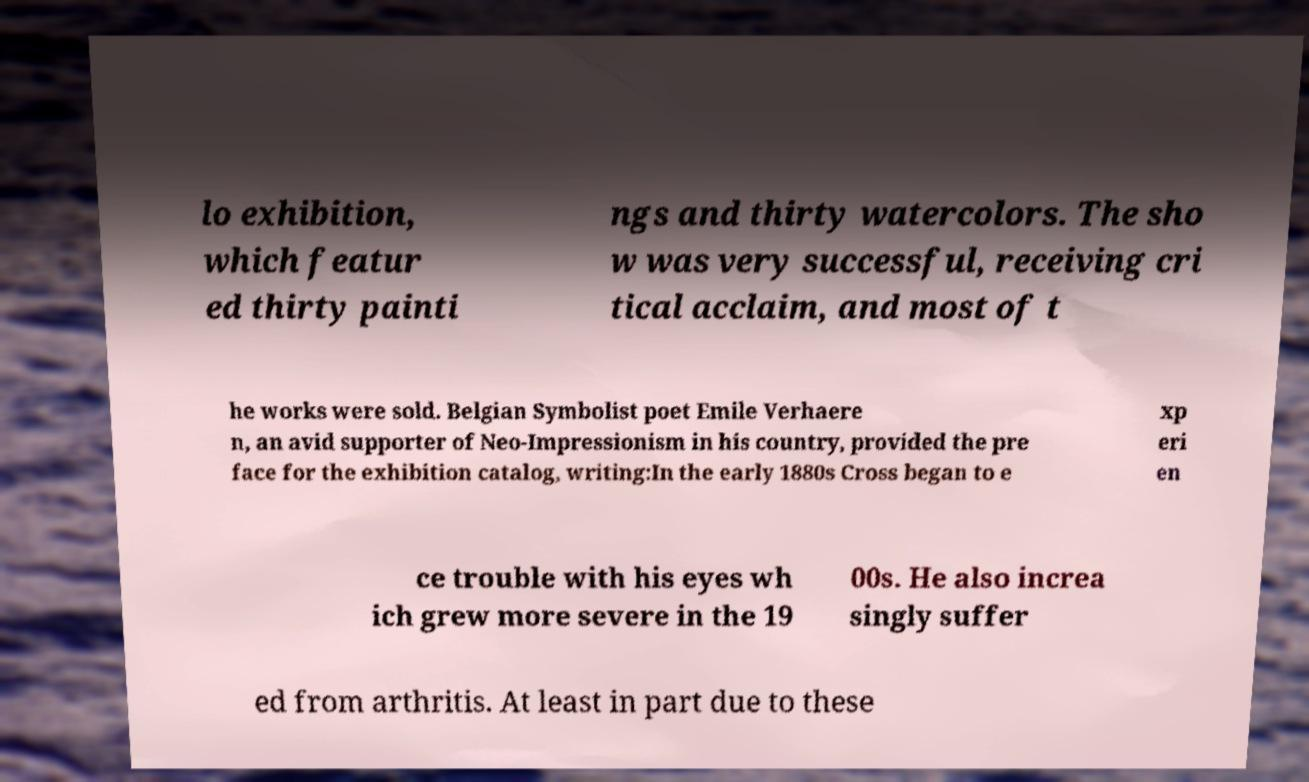There's text embedded in this image that I need extracted. Can you transcribe it verbatim? lo exhibition, which featur ed thirty painti ngs and thirty watercolors. The sho w was very successful, receiving cri tical acclaim, and most of t he works were sold. Belgian Symbolist poet Emile Verhaere n, an avid supporter of Neo-Impressionism in his country, provided the pre face for the exhibition catalog, writing:In the early 1880s Cross began to e xp eri en ce trouble with his eyes wh ich grew more severe in the 19 00s. He also increa singly suffer ed from arthritis. At least in part due to these 